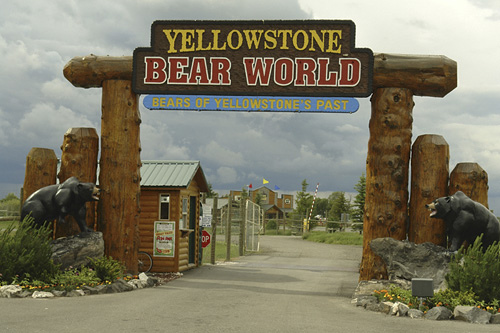<image>
Is there a sign in front of the bear? No. The sign is not in front of the bear. The spatial positioning shows a different relationship between these objects. 